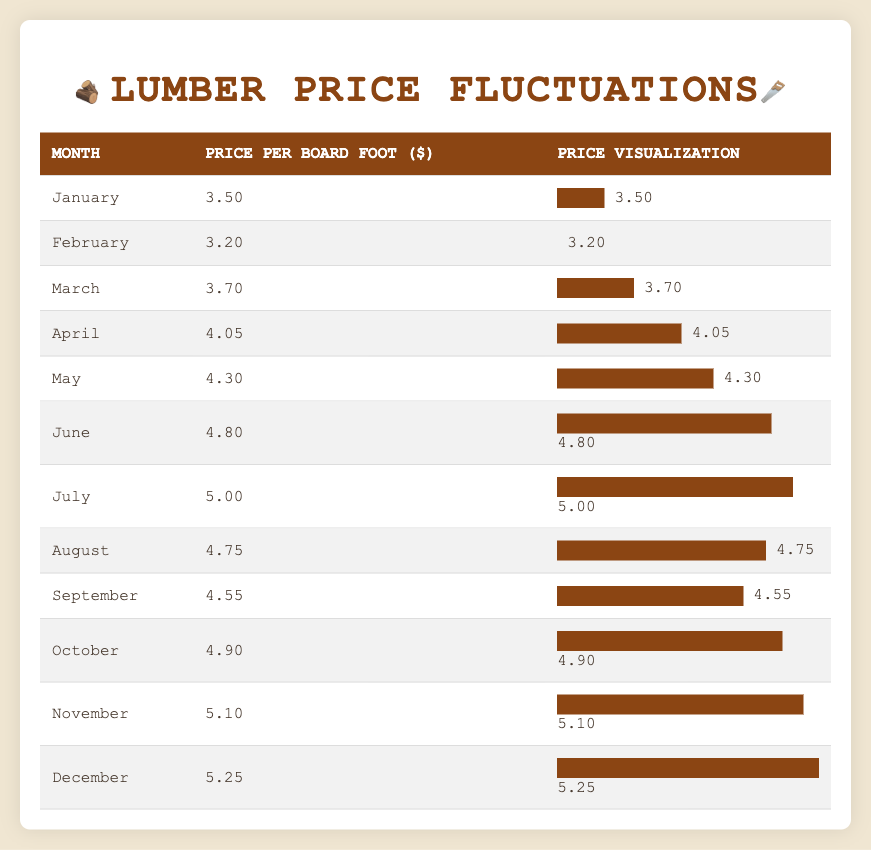What was the lowest lumber price recorded in the table? The table lists lumber prices for each month. Scanning through the "Price per Board Foot" column, the lowest price is found in January at $3.50.
Answer: $3.50 Which month had the highest lumber price? By reviewing the "Price per Board Foot" column, December has the highest price at $5.25 compared to other months listed.
Answer: December What is the average lumber price over the year? To find the average, add all monthly prices: (3.50 + 3.20 + 3.70 + 4.05 + 4.30 + 4.80 + 5.00 + 4.75 + 4.55 + 4.90 + 5.10 + 5.25) = 57.10. Then, divide by 12 months: 57.10 / 12 = 4.76.
Answer: $4.76 Did the lumber prices increase from January to December? Comparing the prices, January's price is $3.50 and December's price is $5.25. Since December's price is higher, it concludes that prices did increase.
Answer: Yes In which month did lumber prices exhibit the largest increase compared to the previous month? Comparing the month-to-month prices, the largest increase is seen from June to July: from $4.80 to $5.00, which is an increase of $0.20. This is larger than increases in other months.
Answer: July What was the price difference between the highest and lowest monthly prices? The highest price is $5.25 in December and the lowest is $3.50 in January. The difference is $5.25 - $3.50 = $1.75.
Answer: $1.75 How many months did the lumber prices exceed $4.50? Looking through the prices, the months with prices over $4.50 are June ($4.80), July ($5.00), August ($4.75), September ($4.55), October ($4.90), November ($5.10), and December ($5.25). There are 7 months in total.
Answer: 7 Was there a month where prices dropped compared to the previous month? Analyzing the price trends reveals that there were some months with price drops. For example, July ($5.00) to August ($4.75) shows a decrease.
Answer: Yes What percentage did the lumber price increase from January to December? The increase from January ($3.50) to December ($5.25) is $5.25 - $3.50 = $1.75. To find the percentage increase relative to January's price, use ($1.75 / $3.50) * 100 = 50%.
Answer: 50% 